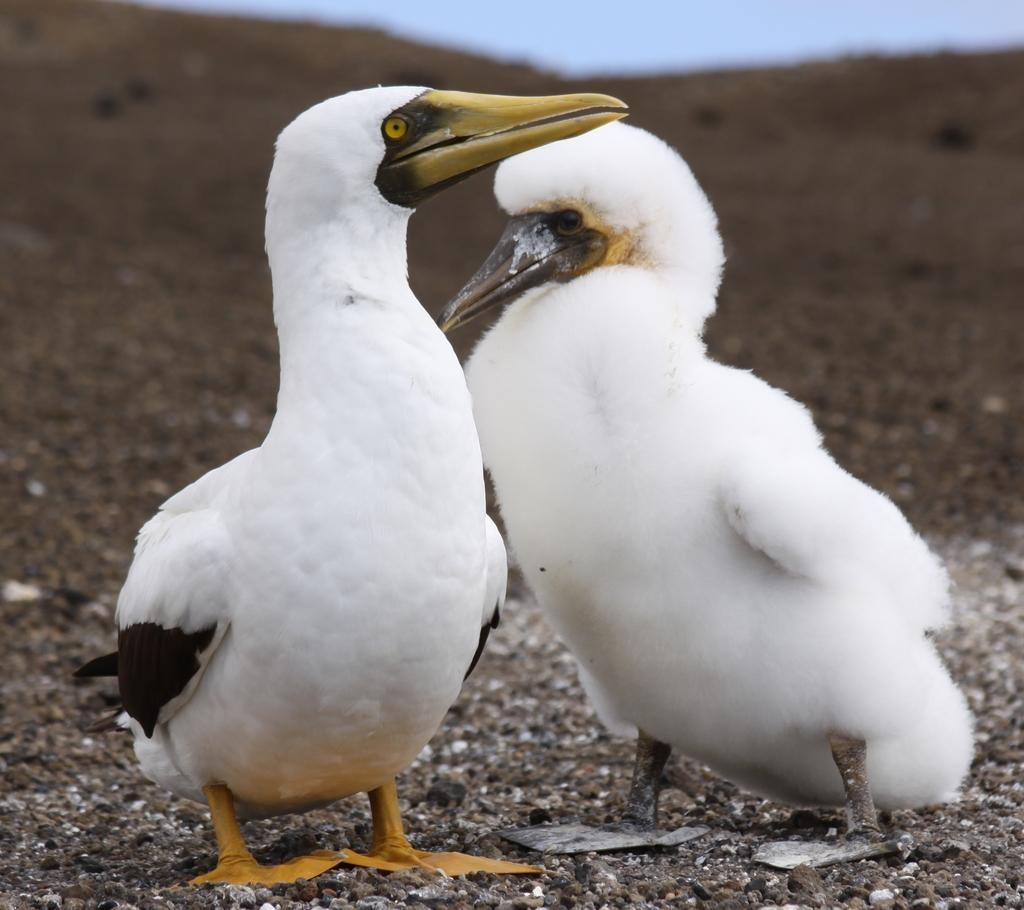What type of animals are in the picture? There are two sea birds in the picture. What are the sea birds doing in the picture? The sea birds are standing. What type of surface is visible at the bottom of the picture? There is soil visible at the bottom of the picture. What is visible at the top of the picture? The sky is visible at the top of the picture. What effect does the porter have on the cart in the image? There is no porter or cart present in the image. What type of cart is being pulled by the sea birds in the image? There are no sea birds pulling a cart in the image; they are simply standing. 